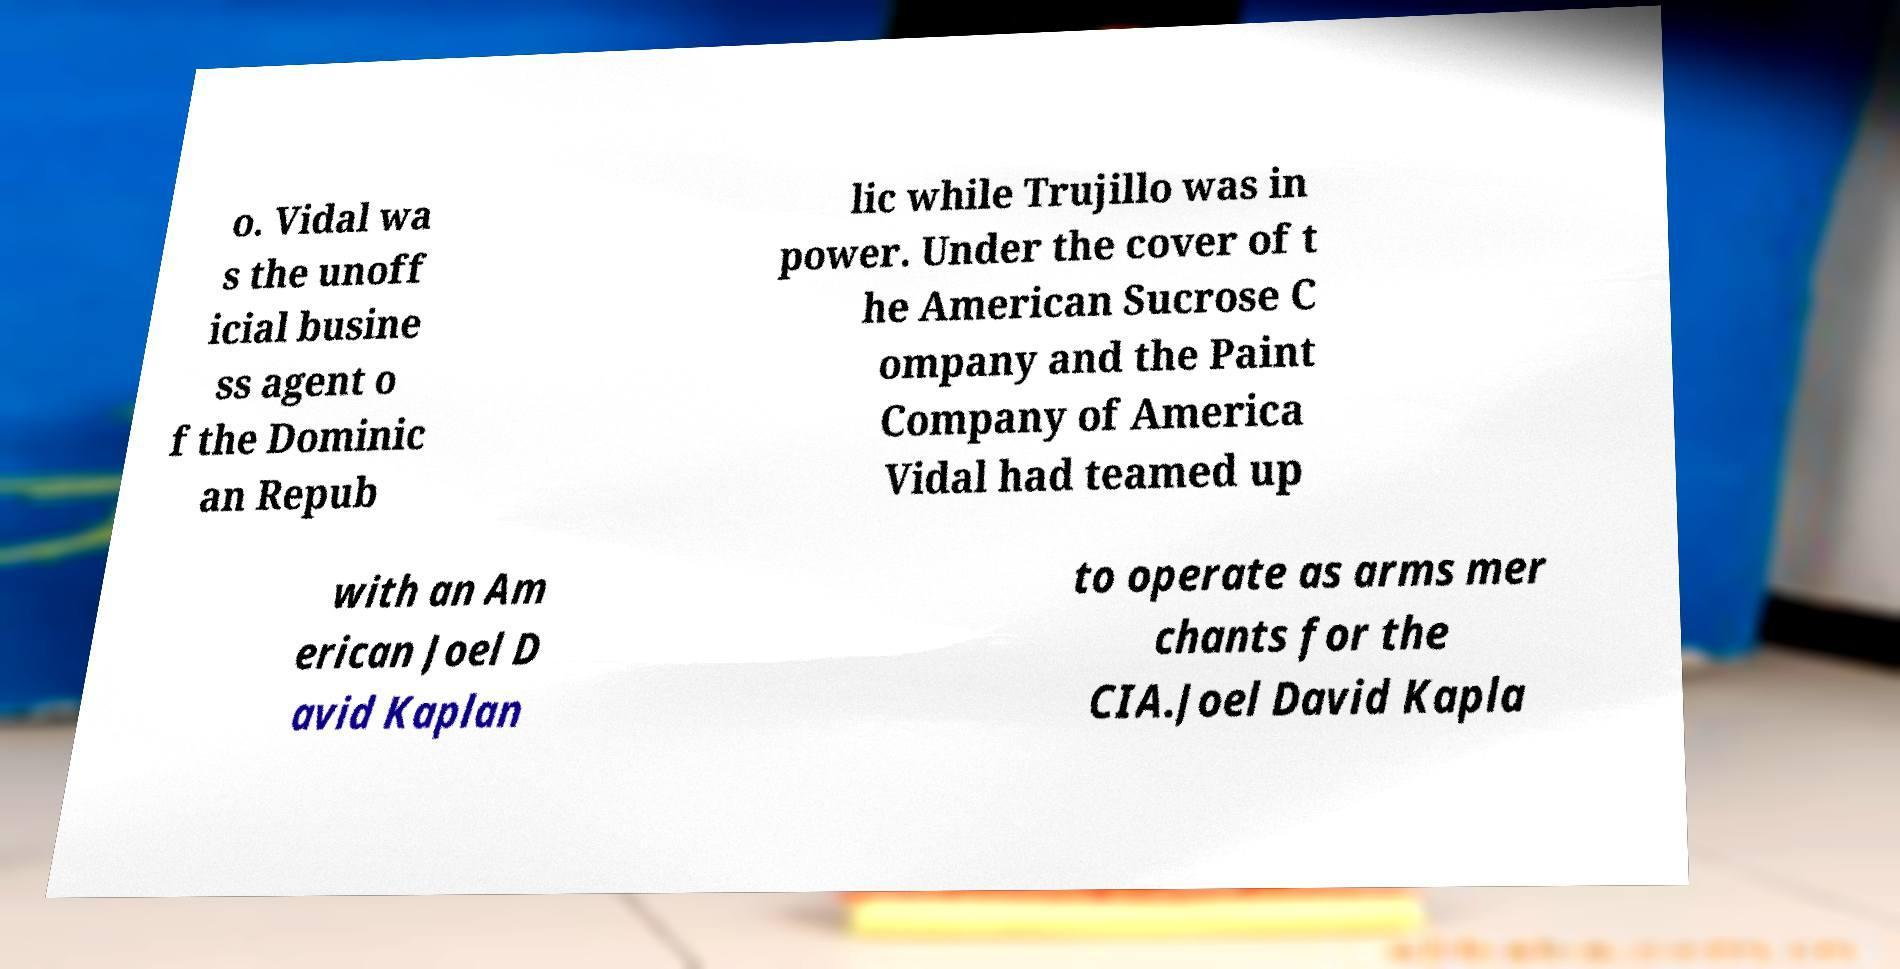What messages or text are displayed in this image? I need them in a readable, typed format. o. Vidal wa s the unoff icial busine ss agent o f the Dominic an Repub lic while Trujillo was in power. Under the cover of t he American Sucrose C ompany and the Paint Company of America Vidal had teamed up with an Am erican Joel D avid Kaplan to operate as arms mer chants for the CIA.Joel David Kapla 